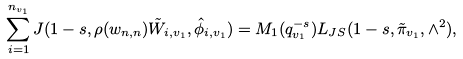Convert formula to latex. <formula><loc_0><loc_0><loc_500><loc_500>\sum _ { i = 1 } ^ { n _ { v _ { 1 } } } J ( 1 - s , \rho ( w _ { n , n } ) \tilde { W } _ { i , v _ { 1 } } , \hat { \phi } _ { i , v _ { 1 } } ) = M _ { 1 } ( q _ { v _ { 1 } } ^ { - s } ) L _ { J S } ( 1 - s , \tilde { \pi } _ { v _ { 1 } } , \wedge ^ { 2 } ) ,</formula> 